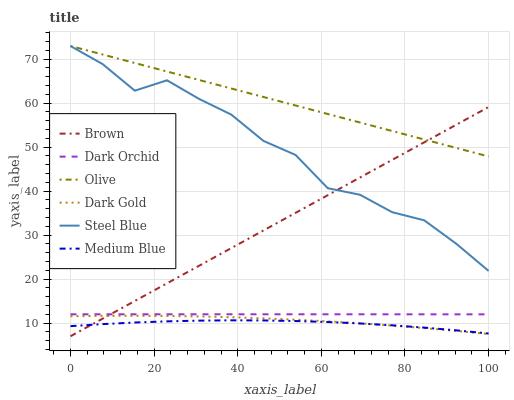Does Medium Blue have the minimum area under the curve?
Answer yes or no. Yes. Does Olive have the maximum area under the curve?
Answer yes or no. Yes. Does Dark Gold have the minimum area under the curve?
Answer yes or no. No. Does Dark Gold have the maximum area under the curve?
Answer yes or no. No. Is Brown the smoothest?
Answer yes or no. Yes. Is Steel Blue the roughest?
Answer yes or no. Yes. Is Dark Gold the smoothest?
Answer yes or no. No. Is Dark Gold the roughest?
Answer yes or no. No. Does Brown have the lowest value?
Answer yes or no. Yes. Does Dark Gold have the lowest value?
Answer yes or no. No. Does Olive have the highest value?
Answer yes or no. Yes. Does Dark Gold have the highest value?
Answer yes or no. No. Is Dark Gold less than Steel Blue?
Answer yes or no. Yes. Is Dark Orchid greater than Dark Gold?
Answer yes or no. Yes. Does Brown intersect Medium Blue?
Answer yes or no. Yes. Is Brown less than Medium Blue?
Answer yes or no. No. Is Brown greater than Medium Blue?
Answer yes or no. No. Does Dark Gold intersect Steel Blue?
Answer yes or no. No. 